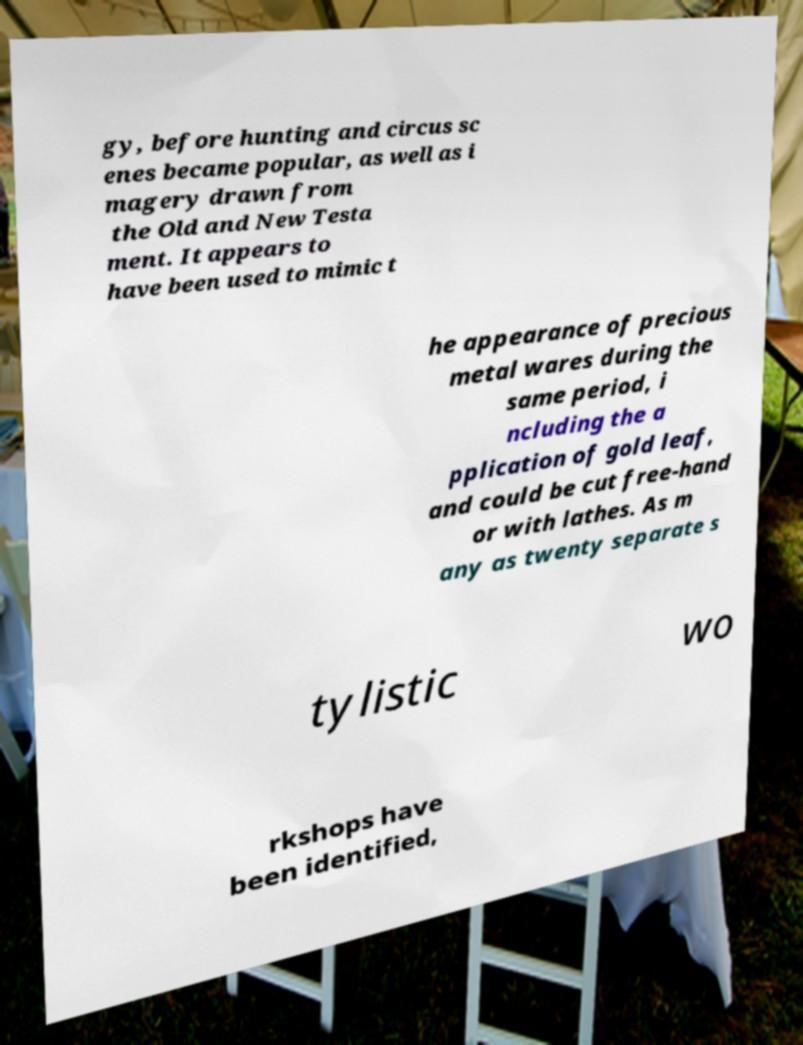Could you assist in decoding the text presented in this image and type it out clearly? gy, before hunting and circus sc enes became popular, as well as i magery drawn from the Old and New Testa ment. It appears to have been used to mimic t he appearance of precious metal wares during the same period, i ncluding the a pplication of gold leaf, and could be cut free-hand or with lathes. As m any as twenty separate s tylistic wo rkshops have been identified, 